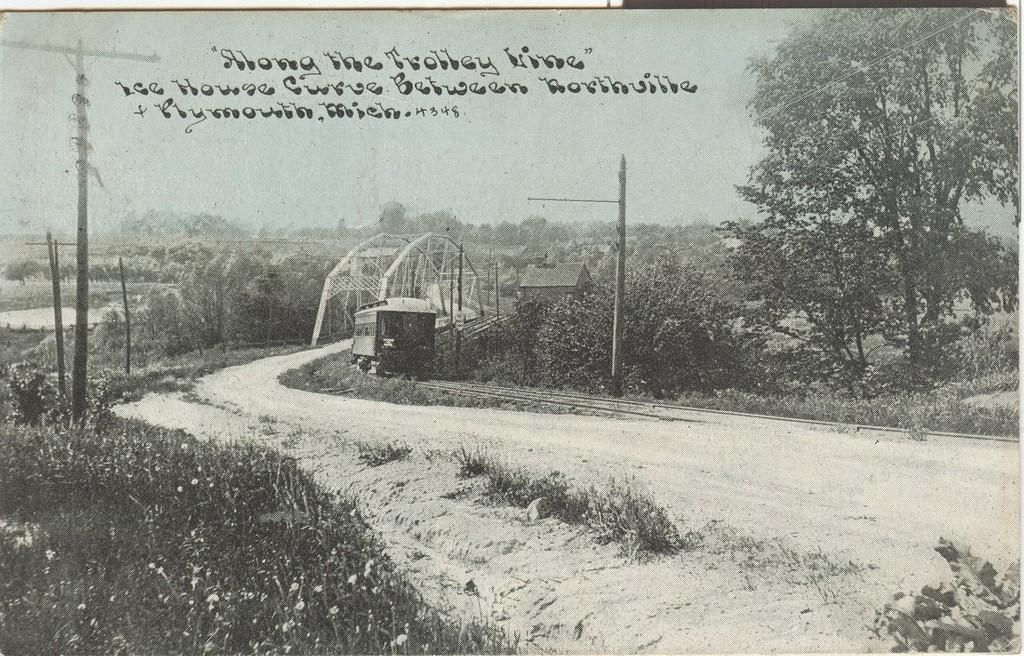What is the color scheme of the photo? The image is a black and white photo. What type of structure can be seen in the photo? There is a bridge in the photo. What type of vegetation is present in the photo? There is grass in the photo. What other objects can be seen in the photo? There are poles, a vehicle, a house, and trees in the photo. What part of the natural environment is visible in the photo? The sky is visible in the photo. Is there any text or writing in the photo? Yes, there is writing on the photo. How many apples are hanging from the bridge in the photo? There are no apples present in the photo; the image is a black and white photo of a bridge, grass, poles, a vehicle, a house, trees, and the sky. What type of hat is the vehicle wearing in the photo? There is no hat present in the photo, as vehicles do not wear hats. 